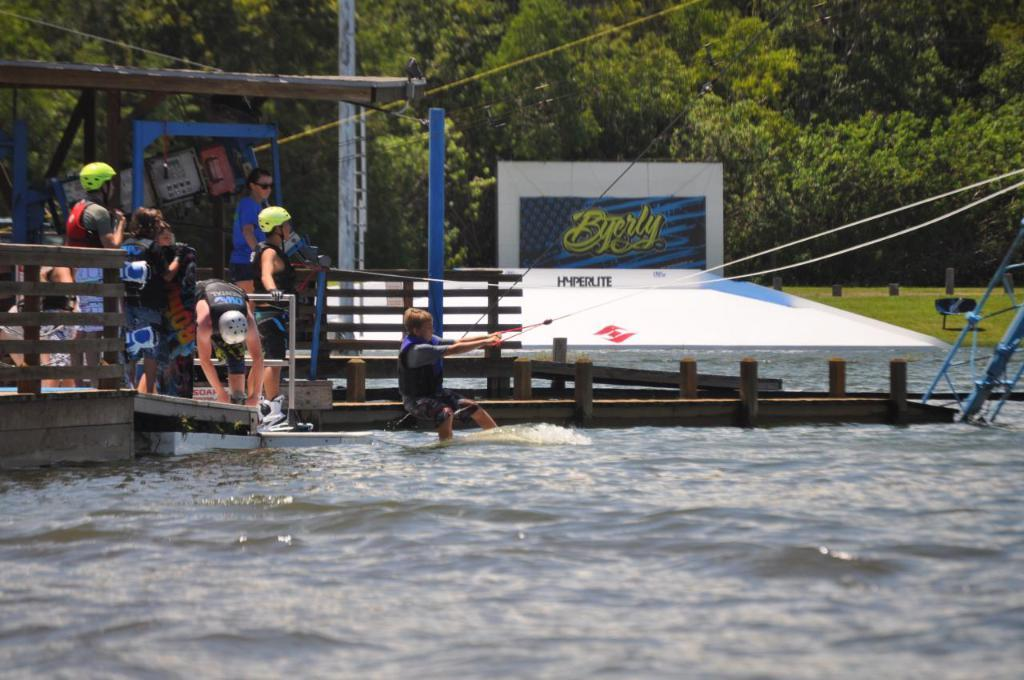Provide a one-sentence caption for the provided image. Someone is getting ready to wakeboard, with a Byerly advertisement in the background. 